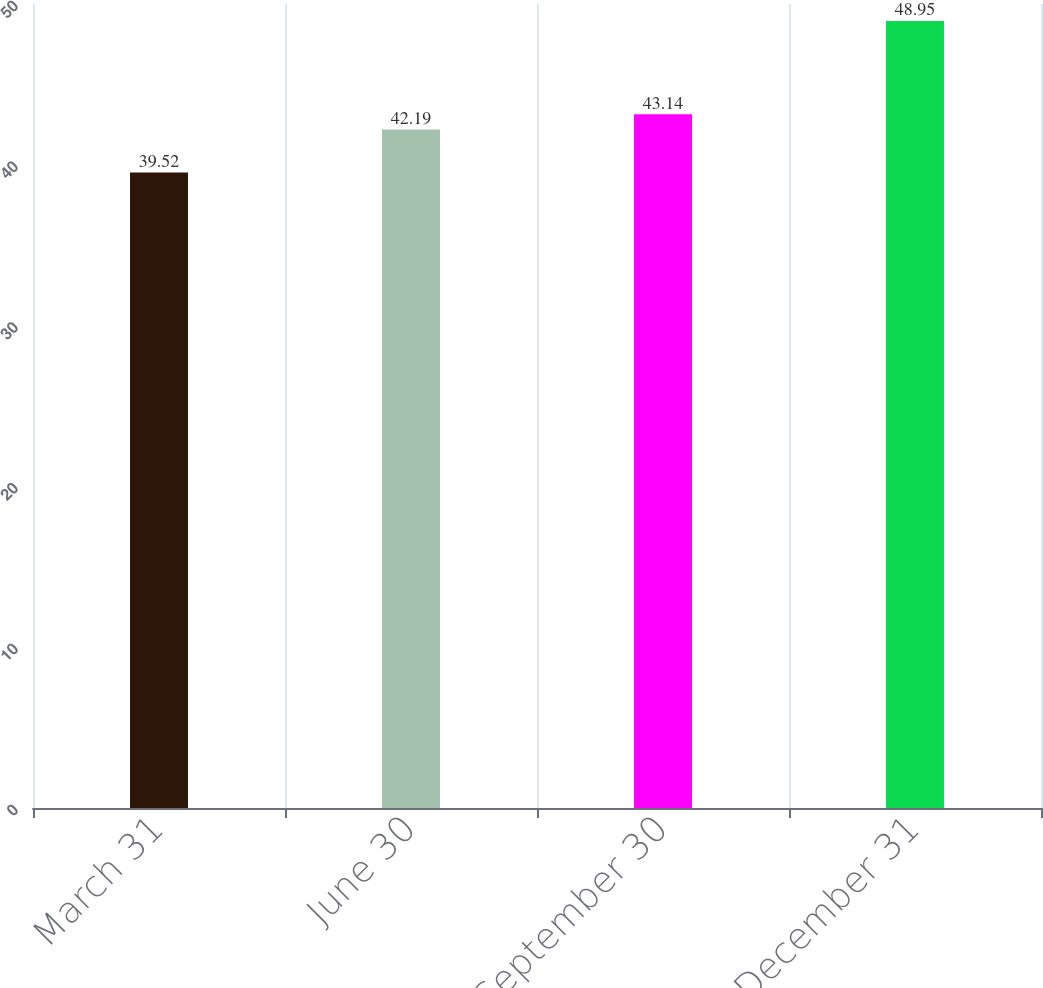Convert chart. <chart><loc_0><loc_0><loc_500><loc_500><bar_chart><fcel>March 31<fcel>June 30<fcel>September 30<fcel>December 31<nl><fcel>39.52<fcel>42.19<fcel>43.14<fcel>48.95<nl></chart> 